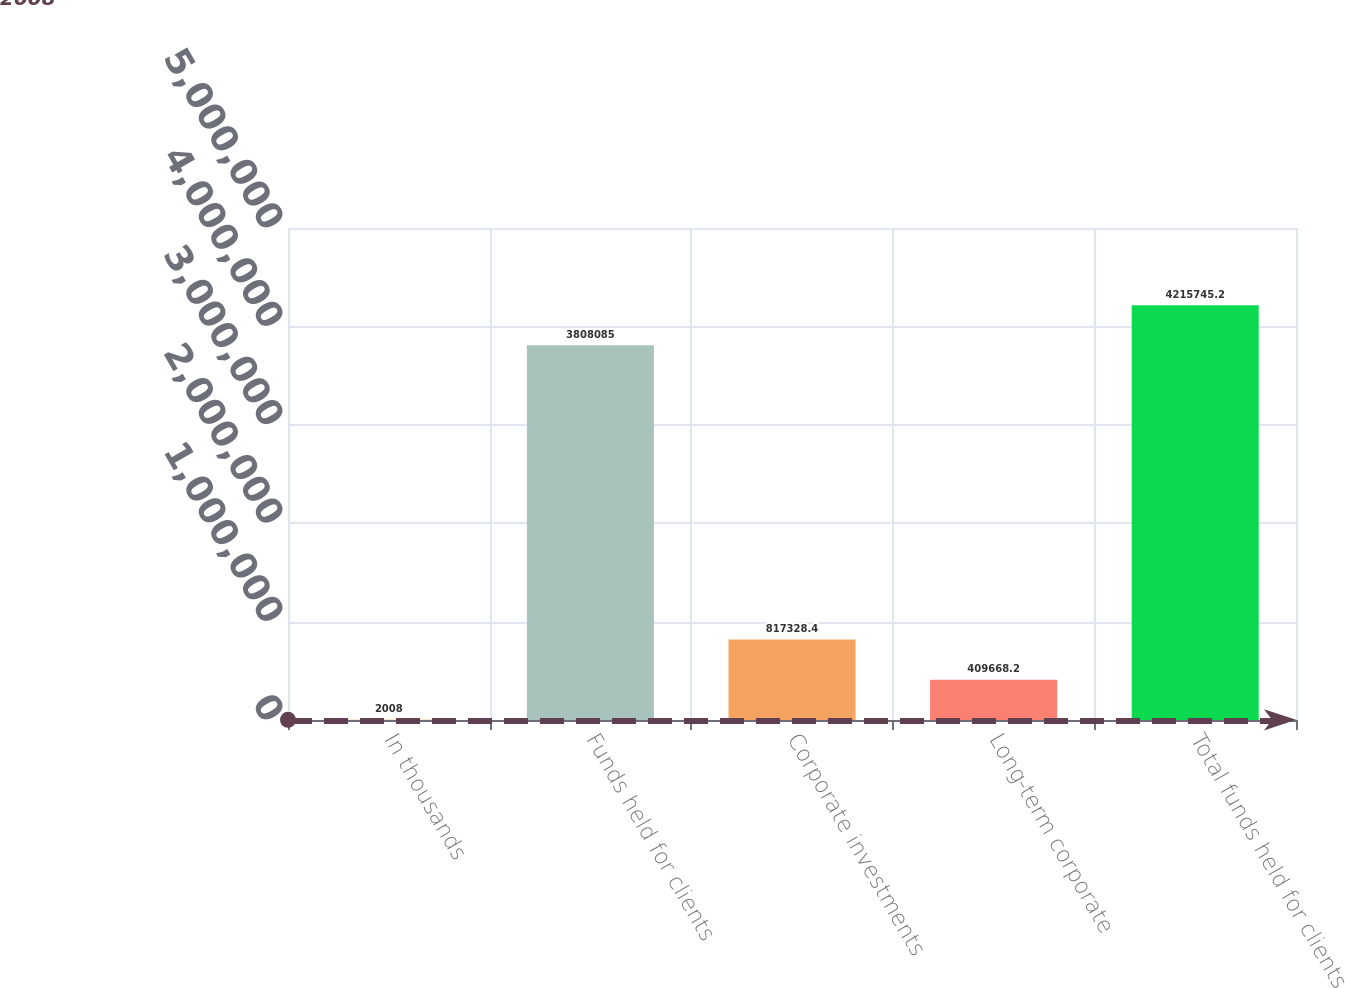<chart> <loc_0><loc_0><loc_500><loc_500><bar_chart><fcel>In thousands<fcel>Funds held for clients<fcel>Corporate investments<fcel>Long-term corporate<fcel>Total funds held for clients<nl><fcel>2008<fcel>3.80808e+06<fcel>817328<fcel>409668<fcel>4.21575e+06<nl></chart> 